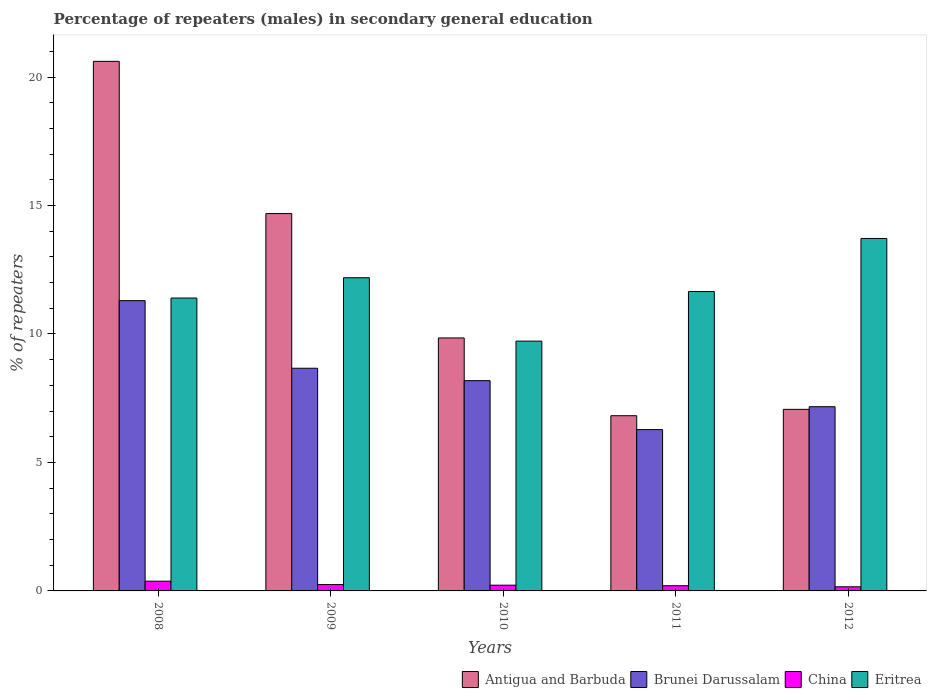How many groups of bars are there?
Offer a terse response. 5. How many bars are there on the 1st tick from the right?
Offer a terse response. 4. What is the percentage of male repeaters in Eritrea in 2010?
Ensure brevity in your answer.  9.72. Across all years, what is the maximum percentage of male repeaters in Eritrea?
Offer a terse response. 13.72. Across all years, what is the minimum percentage of male repeaters in Brunei Darussalam?
Your answer should be very brief. 6.28. What is the total percentage of male repeaters in Brunei Darussalam in the graph?
Make the answer very short. 41.59. What is the difference between the percentage of male repeaters in China in 2009 and that in 2010?
Your answer should be compact. 0.02. What is the difference between the percentage of male repeaters in China in 2008 and the percentage of male repeaters in Antigua and Barbuda in 2012?
Ensure brevity in your answer.  -6.69. What is the average percentage of male repeaters in Antigua and Barbuda per year?
Give a very brief answer. 11.81. In the year 2009, what is the difference between the percentage of male repeaters in China and percentage of male repeaters in Antigua and Barbuda?
Your answer should be very brief. -14.44. What is the ratio of the percentage of male repeaters in Eritrea in 2008 to that in 2012?
Offer a very short reply. 0.83. Is the percentage of male repeaters in Eritrea in 2009 less than that in 2011?
Ensure brevity in your answer.  No. What is the difference between the highest and the second highest percentage of male repeaters in Eritrea?
Your response must be concise. 1.53. What is the difference between the highest and the lowest percentage of male repeaters in China?
Give a very brief answer. 0.22. In how many years, is the percentage of male repeaters in Antigua and Barbuda greater than the average percentage of male repeaters in Antigua and Barbuda taken over all years?
Offer a very short reply. 2. Is the sum of the percentage of male repeaters in Brunei Darussalam in 2010 and 2011 greater than the maximum percentage of male repeaters in Eritrea across all years?
Offer a terse response. Yes. Is it the case that in every year, the sum of the percentage of male repeaters in Brunei Darussalam and percentage of male repeaters in Antigua and Barbuda is greater than the sum of percentage of male repeaters in China and percentage of male repeaters in Eritrea?
Provide a succinct answer. No. What does the 1st bar from the left in 2008 represents?
Your response must be concise. Antigua and Barbuda. What does the 4th bar from the right in 2008 represents?
Provide a succinct answer. Antigua and Barbuda. Is it the case that in every year, the sum of the percentage of male repeaters in Brunei Darussalam and percentage of male repeaters in China is greater than the percentage of male repeaters in Antigua and Barbuda?
Your answer should be very brief. No. How many bars are there?
Make the answer very short. 20. Are the values on the major ticks of Y-axis written in scientific E-notation?
Give a very brief answer. No. Where does the legend appear in the graph?
Your answer should be compact. Bottom right. How many legend labels are there?
Keep it short and to the point. 4. How are the legend labels stacked?
Give a very brief answer. Horizontal. What is the title of the graph?
Offer a terse response. Percentage of repeaters (males) in secondary general education. What is the label or title of the X-axis?
Your response must be concise. Years. What is the label or title of the Y-axis?
Your answer should be compact. % of repeaters. What is the % of repeaters of Antigua and Barbuda in 2008?
Keep it short and to the point. 20.61. What is the % of repeaters of Brunei Darussalam in 2008?
Your answer should be compact. 11.3. What is the % of repeaters in China in 2008?
Your answer should be very brief. 0.38. What is the % of repeaters of Eritrea in 2008?
Provide a succinct answer. 11.4. What is the % of repeaters in Antigua and Barbuda in 2009?
Your response must be concise. 14.69. What is the % of repeaters of Brunei Darussalam in 2009?
Offer a very short reply. 8.67. What is the % of repeaters of China in 2009?
Ensure brevity in your answer.  0.25. What is the % of repeaters of Eritrea in 2009?
Your answer should be compact. 12.19. What is the % of repeaters of Antigua and Barbuda in 2010?
Offer a terse response. 9.85. What is the % of repeaters of Brunei Darussalam in 2010?
Keep it short and to the point. 8.18. What is the % of repeaters of China in 2010?
Your response must be concise. 0.22. What is the % of repeaters in Eritrea in 2010?
Your response must be concise. 9.72. What is the % of repeaters in Antigua and Barbuda in 2011?
Give a very brief answer. 6.82. What is the % of repeaters of Brunei Darussalam in 2011?
Your answer should be very brief. 6.28. What is the % of repeaters of China in 2011?
Offer a terse response. 0.2. What is the % of repeaters in Eritrea in 2011?
Your response must be concise. 11.65. What is the % of repeaters of Antigua and Barbuda in 2012?
Provide a succinct answer. 7.07. What is the % of repeaters in Brunei Darussalam in 2012?
Make the answer very short. 7.17. What is the % of repeaters of China in 2012?
Provide a short and direct response. 0.16. What is the % of repeaters in Eritrea in 2012?
Offer a very short reply. 13.72. Across all years, what is the maximum % of repeaters of Antigua and Barbuda?
Your response must be concise. 20.61. Across all years, what is the maximum % of repeaters of Brunei Darussalam?
Offer a very short reply. 11.3. Across all years, what is the maximum % of repeaters in China?
Offer a terse response. 0.38. Across all years, what is the maximum % of repeaters in Eritrea?
Offer a very short reply. 13.72. Across all years, what is the minimum % of repeaters in Antigua and Barbuda?
Offer a very short reply. 6.82. Across all years, what is the minimum % of repeaters in Brunei Darussalam?
Ensure brevity in your answer.  6.28. Across all years, what is the minimum % of repeaters in China?
Your answer should be compact. 0.16. Across all years, what is the minimum % of repeaters of Eritrea?
Offer a terse response. 9.72. What is the total % of repeaters in Antigua and Barbuda in the graph?
Make the answer very short. 59.03. What is the total % of repeaters of Brunei Darussalam in the graph?
Offer a very short reply. 41.59. What is the total % of repeaters of China in the graph?
Make the answer very short. 1.21. What is the total % of repeaters in Eritrea in the graph?
Your answer should be compact. 58.68. What is the difference between the % of repeaters of Antigua and Barbuda in 2008 and that in 2009?
Ensure brevity in your answer.  5.92. What is the difference between the % of repeaters of Brunei Darussalam in 2008 and that in 2009?
Offer a very short reply. 2.63. What is the difference between the % of repeaters of China in 2008 and that in 2009?
Offer a terse response. 0.13. What is the difference between the % of repeaters in Eritrea in 2008 and that in 2009?
Offer a very short reply. -0.79. What is the difference between the % of repeaters of Antigua and Barbuda in 2008 and that in 2010?
Provide a short and direct response. 10.76. What is the difference between the % of repeaters in Brunei Darussalam in 2008 and that in 2010?
Give a very brief answer. 3.11. What is the difference between the % of repeaters of China in 2008 and that in 2010?
Your answer should be very brief. 0.16. What is the difference between the % of repeaters of Eritrea in 2008 and that in 2010?
Provide a short and direct response. 1.68. What is the difference between the % of repeaters in Antigua and Barbuda in 2008 and that in 2011?
Give a very brief answer. 13.79. What is the difference between the % of repeaters of Brunei Darussalam in 2008 and that in 2011?
Provide a short and direct response. 5.02. What is the difference between the % of repeaters of China in 2008 and that in 2011?
Provide a short and direct response. 0.18. What is the difference between the % of repeaters in Eritrea in 2008 and that in 2011?
Provide a short and direct response. -0.25. What is the difference between the % of repeaters in Antigua and Barbuda in 2008 and that in 2012?
Make the answer very short. 13.54. What is the difference between the % of repeaters in Brunei Darussalam in 2008 and that in 2012?
Make the answer very short. 4.13. What is the difference between the % of repeaters in China in 2008 and that in 2012?
Offer a very short reply. 0.22. What is the difference between the % of repeaters in Eritrea in 2008 and that in 2012?
Make the answer very short. -2.32. What is the difference between the % of repeaters of Antigua and Barbuda in 2009 and that in 2010?
Ensure brevity in your answer.  4.84. What is the difference between the % of repeaters of Brunei Darussalam in 2009 and that in 2010?
Provide a short and direct response. 0.48. What is the difference between the % of repeaters of China in 2009 and that in 2010?
Your answer should be very brief. 0.02. What is the difference between the % of repeaters of Eritrea in 2009 and that in 2010?
Your answer should be very brief. 2.47. What is the difference between the % of repeaters in Antigua and Barbuda in 2009 and that in 2011?
Offer a terse response. 7.87. What is the difference between the % of repeaters of Brunei Darussalam in 2009 and that in 2011?
Your answer should be very brief. 2.39. What is the difference between the % of repeaters of China in 2009 and that in 2011?
Provide a succinct answer. 0.05. What is the difference between the % of repeaters in Eritrea in 2009 and that in 2011?
Your answer should be compact. 0.54. What is the difference between the % of repeaters in Antigua and Barbuda in 2009 and that in 2012?
Make the answer very short. 7.62. What is the difference between the % of repeaters of Brunei Darussalam in 2009 and that in 2012?
Give a very brief answer. 1.5. What is the difference between the % of repeaters in China in 2009 and that in 2012?
Your response must be concise. 0.09. What is the difference between the % of repeaters in Eritrea in 2009 and that in 2012?
Offer a very short reply. -1.53. What is the difference between the % of repeaters in Antigua and Barbuda in 2010 and that in 2011?
Offer a very short reply. 3.03. What is the difference between the % of repeaters in Brunei Darussalam in 2010 and that in 2011?
Your answer should be compact. 1.9. What is the difference between the % of repeaters of China in 2010 and that in 2011?
Keep it short and to the point. 0.02. What is the difference between the % of repeaters in Eritrea in 2010 and that in 2011?
Provide a short and direct response. -1.93. What is the difference between the % of repeaters of Antigua and Barbuda in 2010 and that in 2012?
Make the answer very short. 2.78. What is the difference between the % of repeaters in Brunei Darussalam in 2010 and that in 2012?
Offer a very short reply. 1.01. What is the difference between the % of repeaters in China in 2010 and that in 2012?
Ensure brevity in your answer.  0.06. What is the difference between the % of repeaters of Eritrea in 2010 and that in 2012?
Your response must be concise. -4. What is the difference between the % of repeaters in Antigua and Barbuda in 2011 and that in 2012?
Your answer should be compact. -0.25. What is the difference between the % of repeaters in Brunei Darussalam in 2011 and that in 2012?
Make the answer very short. -0.89. What is the difference between the % of repeaters of China in 2011 and that in 2012?
Offer a very short reply. 0.04. What is the difference between the % of repeaters in Eritrea in 2011 and that in 2012?
Provide a succinct answer. -2.07. What is the difference between the % of repeaters in Antigua and Barbuda in 2008 and the % of repeaters in Brunei Darussalam in 2009?
Your answer should be compact. 11.94. What is the difference between the % of repeaters in Antigua and Barbuda in 2008 and the % of repeaters in China in 2009?
Provide a short and direct response. 20.36. What is the difference between the % of repeaters in Antigua and Barbuda in 2008 and the % of repeaters in Eritrea in 2009?
Offer a terse response. 8.42. What is the difference between the % of repeaters of Brunei Darussalam in 2008 and the % of repeaters of China in 2009?
Offer a terse response. 11.05. What is the difference between the % of repeaters of Brunei Darussalam in 2008 and the % of repeaters of Eritrea in 2009?
Offer a very short reply. -0.89. What is the difference between the % of repeaters of China in 2008 and the % of repeaters of Eritrea in 2009?
Keep it short and to the point. -11.81. What is the difference between the % of repeaters of Antigua and Barbuda in 2008 and the % of repeaters of Brunei Darussalam in 2010?
Offer a very short reply. 12.43. What is the difference between the % of repeaters in Antigua and Barbuda in 2008 and the % of repeaters in China in 2010?
Ensure brevity in your answer.  20.39. What is the difference between the % of repeaters in Antigua and Barbuda in 2008 and the % of repeaters in Eritrea in 2010?
Provide a succinct answer. 10.89. What is the difference between the % of repeaters in Brunei Darussalam in 2008 and the % of repeaters in China in 2010?
Your answer should be compact. 11.07. What is the difference between the % of repeaters of Brunei Darussalam in 2008 and the % of repeaters of Eritrea in 2010?
Your answer should be compact. 1.58. What is the difference between the % of repeaters in China in 2008 and the % of repeaters in Eritrea in 2010?
Ensure brevity in your answer.  -9.34. What is the difference between the % of repeaters in Antigua and Barbuda in 2008 and the % of repeaters in Brunei Darussalam in 2011?
Your answer should be very brief. 14.33. What is the difference between the % of repeaters in Antigua and Barbuda in 2008 and the % of repeaters in China in 2011?
Give a very brief answer. 20.41. What is the difference between the % of repeaters of Antigua and Barbuda in 2008 and the % of repeaters of Eritrea in 2011?
Make the answer very short. 8.96. What is the difference between the % of repeaters in Brunei Darussalam in 2008 and the % of repeaters in China in 2011?
Your answer should be compact. 11.09. What is the difference between the % of repeaters in Brunei Darussalam in 2008 and the % of repeaters in Eritrea in 2011?
Provide a succinct answer. -0.35. What is the difference between the % of repeaters in China in 2008 and the % of repeaters in Eritrea in 2011?
Ensure brevity in your answer.  -11.27. What is the difference between the % of repeaters of Antigua and Barbuda in 2008 and the % of repeaters of Brunei Darussalam in 2012?
Keep it short and to the point. 13.44. What is the difference between the % of repeaters in Antigua and Barbuda in 2008 and the % of repeaters in China in 2012?
Your answer should be very brief. 20.45. What is the difference between the % of repeaters of Antigua and Barbuda in 2008 and the % of repeaters of Eritrea in 2012?
Provide a short and direct response. 6.89. What is the difference between the % of repeaters of Brunei Darussalam in 2008 and the % of repeaters of China in 2012?
Your answer should be compact. 11.14. What is the difference between the % of repeaters of Brunei Darussalam in 2008 and the % of repeaters of Eritrea in 2012?
Make the answer very short. -2.42. What is the difference between the % of repeaters in China in 2008 and the % of repeaters in Eritrea in 2012?
Provide a succinct answer. -13.34. What is the difference between the % of repeaters of Antigua and Barbuda in 2009 and the % of repeaters of Brunei Darussalam in 2010?
Provide a short and direct response. 6.5. What is the difference between the % of repeaters of Antigua and Barbuda in 2009 and the % of repeaters of China in 2010?
Provide a succinct answer. 14.46. What is the difference between the % of repeaters in Antigua and Barbuda in 2009 and the % of repeaters in Eritrea in 2010?
Ensure brevity in your answer.  4.96. What is the difference between the % of repeaters in Brunei Darussalam in 2009 and the % of repeaters in China in 2010?
Make the answer very short. 8.44. What is the difference between the % of repeaters of Brunei Darussalam in 2009 and the % of repeaters of Eritrea in 2010?
Make the answer very short. -1.06. What is the difference between the % of repeaters in China in 2009 and the % of repeaters in Eritrea in 2010?
Make the answer very short. -9.47. What is the difference between the % of repeaters of Antigua and Barbuda in 2009 and the % of repeaters of Brunei Darussalam in 2011?
Offer a terse response. 8.41. What is the difference between the % of repeaters in Antigua and Barbuda in 2009 and the % of repeaters in China in 2011?
Make the answer very short. 14.48. What is the difference between the % of repeaters of Antigua and Barbuda in 2009 and the % of repeaters of Eritrea in 2011?
Offer a terse response. 3.03. What is the difference between the % of repeaters of Brunei Darussalam in 2009 and the % of repeaters of China in 2011?
Your answer should be compact. 8.46. What is the difference between the % of repeaters in Brunei Darussalam in 2009 and the % of repeaters in Eritrea in 2011?
Offer a very short reply. -2.98. What is the difference between the % of repeaters in China in 2009 and the % of repeaters in Eritrea in 2011?
Provide a succinct answer. -11.4. What is the difference between the % of repeaters in Antigua and Barbuda in 2009 and the % of repeaters in Brunei Darussalam in 2012?
Your response must be concise. 7.52. What is the difference between the % of repeaters in Antigua and Barbuda in 2009 and the % of repeaters in China in 2012?
Keep it short and to the point. 14.52. What is the difference between the % of repeaters in Antigua and Barbuda in 2009 and the % of repeaters in Eritrea in 2012?
Your answer should be very brief. 0.97. What is the difference between the % of repeaters of Brunei Darussalam in 2009 and the % of repeaters of China in 2012?
Give a very brief answer. 8.51. What is the difference between the % of repeaters in Brunei Darussalam in 2009 and the % of repeaters in Eritrea in 2012?
Provide a succinct answer. -5.05. What is the difference between the % of repeaters of China in 2009 and the % of repeaters of Eritrea in 2012?
Offer a very short reply. -13.47. What is the difference between the % of repeaters of Antigua and Barbuda in 2010 and the % of repeaters of Brunei Darussalam in 2011?
Your answer should be very brief. 3.57. What is the difference between the % of repeaters in Antigua and Barbuda in 2010 and the % of repeaters in China in 2011?
Keep it short and to the point. 9.64. What is the difference between the % of repeaters in Antigua and Barbuda in 2010 and the % of repeaters in Eritrea in 2011?
Your response must be concise. -1.81. What is the difference between the % of repeaters in Brunei Darussalam in 2010 and the % of repeaters in China in 2011?
Provide a succinct answer. 7.98. What is the difference between the % of repeaters of Brunei Darussalam in 2010 and the % of repeaters of Eritrea in 2011?
Your answer should be compact. -3.47. What is the difference between the % of repeaters of China in 2010 and the % of repeaters of Eritrea in 2011?
Your response must be concise. -11.43. What is the difference between the % of repeaters in Antigua and Barbuda in 2010 and the % of repeaters in Brunei Darussalam in 2012?
Keep it short and to the point. 2.68. What is the difference between the % of repeaters in Antigua and Barbuda in 2010 and the % of repeaters in China in 2012?
Your response must be concise. 9.68. What is the difference between the % of repeaters in Antigua and Barbuda in 2010 and the % of repeaters in Eritrea in 2012?
Give a very brief answer. -3.87. What is the difference between the % of repeaters of Brunei Darussalam in 2010 and the % of repeaters of China in 2012?
Keep it short and to the point. 8.02. What is the difference between the % of repeaters in Brunei Darussalam in 2010 and the % of repeaters in Eritrea in 2012?
Offer a very short reply. -5.53. What is the difference between the % of repeaters in China in 2010 and the % of repeaters in Eritrea in 2012?
Your answer should be very brief. -13.49. What is the difference between the % of repeaters in Antigua and Barbuda in 2011 and the % of repeaters in Brunei Darussalam in 2012?
Keep it short and to the point. -0.35. What is the difference between the % of repeaters in Antigua and Barbuda in 2011 and the % of repeaters in China in 2012?
Your answer should be compact. 6.66. What is the difference between the % of repeaters in Antigua and Barbuda in 2011 and the % of repeaters in Eritrea in 2012?
Provide a short and direct response. -6.9. What is the difference between the % of repeaters of Brunei Darussalam in 2011 and the % of repeaters of China in 2012?
Provide a succinct answer. 6.12. What is the difference between the % of repeaters of Brunei Darussalam in 2011 and the % of repeaters of Eritrea in 2012?
Ensure brevity in your answer.  -7.44. What is the difference between the % of repeaters of China in 2011 and the % of repeaters of Eritrea in 2012?
Your answer should be compact. -13.51. What is the average % of repeaters of Antigua and Barbuda per year?
Provide a short and direct response. 11.81. What is the average % of repeaters in Brunei Darussalam per year?
Make the answer very short. 8.32. What is the average % of repeaters in China per year?
Offer a terse response. 0.24. What is the average % of repeaters of Eritrea per year?
Ensure brevity in your answer.  11.74. In the year 2008, what is the difference between the % of repeaters of Antigua and Barbuda and % of repeaters of Brunei Darussalam?
Ensure brevity in your answer.  9.31. In the year 2008, what is the difference between the % of repeaters of Antigua and Barbuda and % of repeaters of China?
Provide a succinct answer. 20.23. In the year 2008, what is the difference between the % of repeaters in Antigua and Barbuda and % of repeaters in Eritrea?
Your answer should be compact. 9.21. In the year 2008, what is the difference between the % of repeaters in Brunei Darussalam and % of repeaters in China?
Offer a terse response. 10.92. In the year 2008, what is the difference between the % of repeaters of Brunei Darussalam and % of repeaters of Eritrea?
Your response must be concise. -0.1. In the year 2008, what is the difference between the % of repeaters in China and % of repeaters in Eritrea?
Provide a short and direct response. -11.02. In the year 2009, what is the difference between the % of repeaters in Antigua and Barbuda and % of repeaters in Brunei Darussalam?
Your response must be concise. 6.02. In the year 2009, what is the difference between the % of repeaters in Antigua and Barbuda and % of repeaters in China?
Ensure brevity in your answer.  14.44. In the year 2009, what is the difference between the % of repeaters of Antigua and Barbuda and % of repeaters of Eritrea?
Your answer should be compact. 2.5. In the year 2009, what is the difference between the % of repeaters in Brunei Darussalam and % of repeaters in China?
Provide a succinct answer. 8.42. In the year 2009, what is the difference between the % of repeaters of Brunei Darussalam and % of repeaters of Eritrea?
Provide a succinct answer. -3.52. In the year 2009, what is the difference between the % of repeaters in China and % of repeaters in Eritrea?
Ensure brevity in your answer.  -11.94. In the year 2010, what is the difference between the % of repeaters of Antigua and Barbuda and % of repeaters of Brunei Darussalam?
Provide a succinct answer. 1.66. In the year 2010, what is the difference between the % of repeaters of Antigua and Barbuda and % of repeaters of China?
Keep it short and to the point. 9.62. In the year 2010, what is the difference between the % of repeaters of Antigua and Barbuda and % of repeaters of Eritrea?
Provide a short and direct response. 0.12. In the year 2010, what is the difference between the % of repeaters in Brunei Darussalam and % of repeaters in China?
Provide a short and direct response. 7.96. In the year 2010, what is the difference between the % of repeaters of Brunei Darussalam and % of repeaters of Eritrea?
Offer a very short reply. -1.54. In the year 2010, what is the difference between the % of repeaters in China and % of repeaters in Eritrea?
Your response must be concise. -9.5. In the year 2011, what is the difference between the % of repeaters of Antigua and Barbuda and % of repeaters of Brunei Darussalam?
Your answer should be compact. 0.54. In the year 2011, what is the difference between the % of repeaters of Antigua and Barbuda and % of repeaters of China?
Provide a short and direct response. 6.62. In the year 2011, what is the difference between the % of repeaters in Antigua and Barbuda and % of repeaters in Eritrea?
Your answer should be very brief. -4.83. In the year 2011, what is the difference between the % of repeaters in Brunei Darussalam and % of repeaters in China?
Offer a very short reply. 6.08. In the year 2011, what is the difference between the % of repeaters in Brunei Darussalam and % of repeaters in Eritrea?
Your answer should be very brief. -5.37. In the year 2011, what is the difference between the % of repeaters of China and % of repeaters of Eritrea?
Offer a terse response. -11.45. In the year 2012, what is the difference between the % of repeaters of Antigua and Barbuda and % of repeaters of Brunei Darussalam?
Your answer should be very brief. -0.1. In the year 2012, what is the difference between the % of repeaters in Antigua and Barbuda and % of repeaters in China?
Offer a very short reply. 6.91. In the year 2012, what is the difference between the % of repeaters in Antigua and Barbuda and % of repeaters in Eritrea?
Provide a short and direct response. -6.65. In the year 2012, what is the difference between the % of repeaters of Brunei Darussalam and % of repeaters of China?
Offer a very short reply. 7.01. In the year 2012, what is the difference between the % of repeaters of Brunei Darussalam and % of repeaters of Eritrea?
Your answer should be compact. -6.55. In the year 2012, what is the difference between the % of repeaters of China and % of repeaters of Eritrea?
Offer a terse response. -13.56. What is the ratio of the % of repeaters in Antigua and Barbuda in 2008 to that in 2009?
Give a very brief answer. 1.4. What is the ratio of the % of repeaters in Brunei Darussalam in 2008 to that in 2009?
Your answer should be very brief. 1.3. What is the ratio of the % of repeaters of China in 2008 to that in 2009?
Your response must be concise. 1.53. What is the ratio of the % of repeaters of Eritrea in 2008 to that in 2009?
Provide a succinct answer. 0.94. What is the ratio of the % of repeaters of Antigua and Barbuda in 2008 to that in 2010?
Offer a very short reply. 2.09. What is the ratio of the % of repeaters of Brunei Darussalam in 2008 to that in 2010?
Your response must be concise. 1.38. What is the ratio of the % of repeaters in China in 2008 to that in 2010?
Give a very brief answer. 1.69. What is the ratio of the % of repeaters in Eritrea in 2008 to that in 2010?
Provide a short and direct response. 1.17. What is the ratio of the % of repeaters of Antigua and Barbuda in 2008 to that in 2011?
Provide a succinct answer. 3.02. What is the ratio of the % of repeaters in Brunei Darussalam in 2008 to that in 2011?
Offer a very short reply. 1.8. What is the ratio of the % of repeaters of China in 2008 to that in 2011?
Ensure brevity in your answer.  1.87. What is the ratio of the % of repeaters in Eritrea in 2008 to that in 2011?
Your answer should be very brief. 0.98. What is the ratio of the % of repeaters of Antigua and Barbuda in 2008 to that in 2012?
Provide a succinct answer. 2.92. What is the ratio of the % of repeaters of Brunei Darussalam in 2008 to that in 2012?
Your answer should be very brief. 1.58. What is the ratio of the % of repeaters in China in 2008 to that in 2012?
Ensure brevity in your answer.  2.36. What is the ratio of the % of repeaters in Eritrea in 2008 to that in 2012?
Offer a terse response. 0.83. What is the ratio of the % of repeaters of Antigua and Barbuda in 2009 to that in 2010?
Your answer should be compact. 1.49. What is the ratio of the % of repeaters in Brunei Darussalam in 2009 to that in 2010?
Provide a succinct answer. 1.06. What is the ratio of the % of repeaters in China in 2009 to that in 2010?
Give a very brief answer. 1.11. What is the ratio of the % of repeaters of Eritrea in 2009 to that in 2010?
Your response must be concise. 1.25. What is the ratio of the % of repeaters of Antigua and Barbuda in 2009 to that in 2011?
Your response must be concise. 2.15. What is the ratio of the % of repeaters in Brunei Darussalam in 2009 to that in 2011?
Your response must be concise. 1.38. What is the ratio of the % of repeaters in China in 2009 to that in 2011?
Offer a very short reply. 1.22. What is the ratio of the % of repeaters in Eritrea in 2009 to that in 2011?
Your response must be concise. 1.05. What is the ratio of the % of repeaters in Antigua and Barbuda in 2009 to that in 2012?
Offer a terse response. 2.08. What is the ratio of the % of repeaters of Brunei Darussalam in 2009 to that in 2012?
Your response must be concise. 1.21. What is the ratio of the % of repeaters in China in 2009 to that in 2012?
Provide a short and direct response. 1.54. What is the ratio of the % of repeaters in Eritrea in 2009 to that in 2012?
Provide a succinct answer. 0.89. What is the ratio of the % of repeaters in Antigua and Barbuda in 2010 to that in 2011?
Your answer should be very brief. 1.44. What is the ratio of the % of repeaters of Brunei Darussalam in 2010 to that in 2011?
Provide a succinct answer. 1.3. What is the ratio of the % of repeaters in China in 2010 to that in 2011?
Your response must be concise. 1.11. What is the ratio of the % of repeaters of Eritrea in 2010 to that in 2011?
Provide a succinct answer. 0.83. What is the ratio of the % of repeaters in Antigua and Barbuda in 2010 to that in 2012?
Your answer should be compact. 1.39. What is the ratio of the % of repeaters in Brunei Darussalam in 2010 to that in 2012?
Make the answer very short. 1.14. What is the ratio of the % of repeaters in China in 2010 to that in 2012?
Ensure brevity in your answer.  1.39. What is the ratio of the % of repeaters of Eritrea in 2010 to that in 2012?
Offer a terse response. 0.71. What is the ratio of the % of repeaters of Brunei Darussalam in 2011 to that in 2012?
Offer a very short reply. 0.88. What is the ratio of the % of repeaters in China in 2011 to that in 2012?
Offer a terse response. 1.26. What is the ratio of the % of repeaters of Eritrea in 2011 to that in 2012?
Offer a terse response. 0.85. What is the difference between the highest and the second highest % of repeaters in Antigua and Barbuda?
Provide a succinct answer. 5.92. What is the difference between the highest and the second highest % of repeaters of Brunei Darussalam?
Provide a succinct answer. 2.63. What is the difference between the highest and the second highest % of repeaters of China?
Your response must be concise. 0.13. What is the difference between the highest and the second highest % of repeaters in Eritrea?
Provide a short and direct response. 1.53. What is the difference between the highest and the lowest % of repeaters of Antigua and Barbuda?
Offer a very short reply. 13.79. What is the difference between the highest and the lowest % of repeaters in Brunei Darussalam?
Offer a terse response. 5.02. What is the difference between the highest and the lowest % of repeaters in China?
Keep it short and to the point. 0.22. What is the difference between the highest and the lowest % of repeaters in Eritrea?
Your answer should be very brief. 4. 